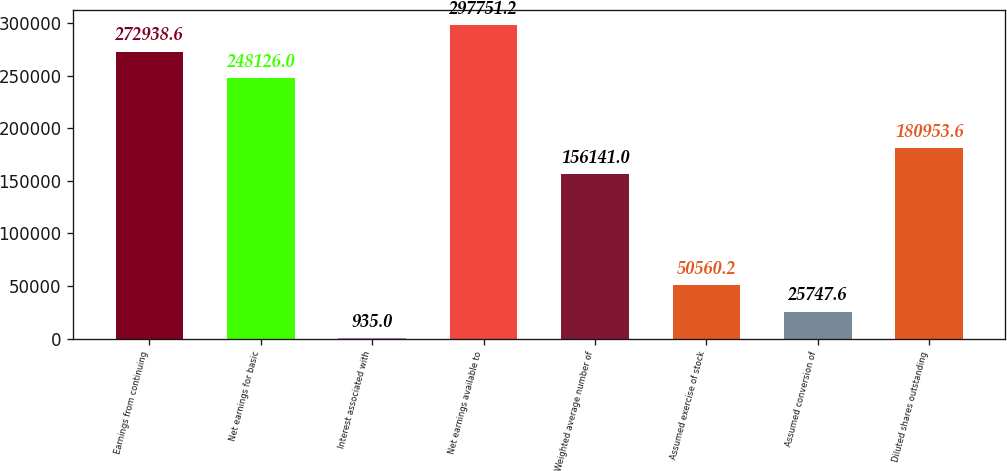Convert chart to OTSL. <chart><loc_0><loc_0><loc_500><loc_500><bar_chart><fcel>Earnings from continuing<fcel>Net earnings for basic<fcel>Interest associated with<fcel>Net earnings available to<fcel>Weighted average number of<fcel>Assumed exercise of stock<fcel>Assumed conversion of<fcel>Diluted shares outstanding<nl><fcel>272939<fcel>248126<fcel>935<fcel>297751<fcel>156141<fcel>50560.2<fcel>25747.6<fcel>180954<nl></chart> 